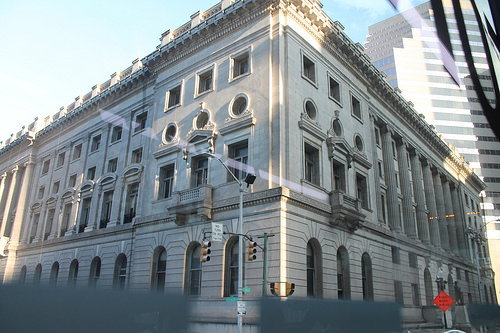<image>
Is there a window to the left of the window? Yes. From this viewpoint, the window is positioned to the left side relative to the window. 